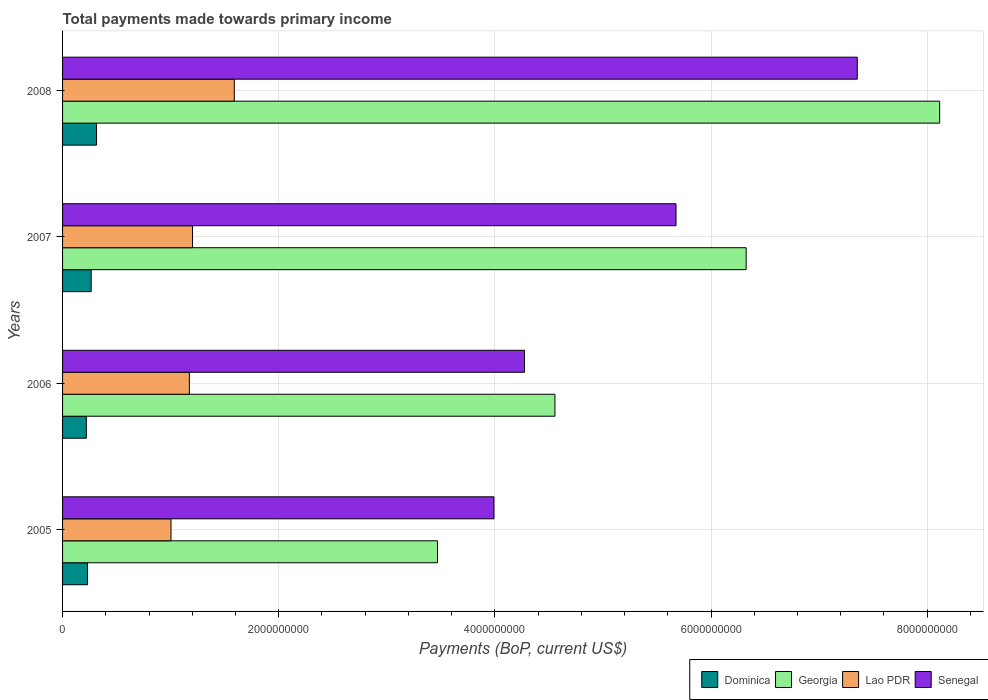How many different coloured bars are there?
Offer a terse response. 4. Are the number of bars per tick equal to the number of legend labels?
Provide a short and direct response. Yes. How many bars are there on the 4th tick from the top?
Your response must be concise. 4. How many bars are there on the 2nd tick from the bottom?
Your answer should be compact. 4. What is the label of the 2nd group of bars from the top?
Provide a short and direct response. 2007. In how many cases, is the number of bars for a given year not equal to the number of legend labels?
Your response must be concise. 0. What is the total payments made towards primary income in Lao PDR in 2008?
Make the answer very short. 1.59e+09. Across all years, what is the maximum total payments made towards primary income in Dominica?
Provide a short and direct response. 3.14e+08. Across all years, what is the minimum total payments made towards primary income in Georgia?
Your response must be concise. 3.47e+09. In which year was the total payments made towards primary income in Dominica minimum?
Provide a short and direct response. 2006. What is the total total payments made towards primary income in Senegal in the graph?
Ensure brevity in your answer.  2.13e+1. What is the difference between the total payments made towards primary income in Dominica in 2007 and that in 2008?
Provide a short and direct response. -4.96e+07. What is the difference between the total payments made towards primary income in Georgia in 2008 and the total payments made towards primary income in Senegal in 2007?
Your response must be concise. 2.44e+09. What is the average total payments made towards primary income in Dominica per year?
Your response must be concise. 2.57e+08. In the year 2007, what is the difference between the total payments made towards primary income in Senegal and total payments made towards primary income in Dominica?
Your response must be concise. 5.41e+09. In how many years, is the total payments made towards primary income in Senegal greater than 8000000000 US$?
Your response must be concise. 0. What is the ratio of the total payments made towards primary income in Senegal in 2005 to that in 2006?
Offer a very short reply. 0.93. Is the difference between the total payments made towards primary income in Senegal in 2007 and 2008 greater than the difference between the total payments made towards primary income in Dominica in 2007 and 2008?
Offer a terse response. No. What is the difference between the highest and the second highest total payments made towards primary income in Dominica?
Your answer should be very brief. 4.96e+07. What is the difference between the highest and the lowest total payments made towards primary income in Georgia?
Your answer should be compact. 4.65e+09. In how many years, is the total payments made towards primary income in Senegal greater than the average total payments made towards primary income in Senegal taken over all years?
Your answer should be compact. 2. Is the sum of the total payments made towards primary income in Lao PDR in 2006 and 2008 greater than the maximum total payments made towards primary income in Georgia across all years?
Offer a very short reply. No. Is it the case that in every year, the sum of the total payments made towards primary income in Lao PDR and total payments made towards primary income in Georgia is greater than the sum of total payments made towards primary income in Dominica and total payments made towards primary income in Senegal?
Make the answer very short. Yes. What does the 3rd bar from the top in 2006 represents?
Your answer should be compact. Georgia. What does the 1st bar from the bottom in 2005 represents?
Make the answer very short. Dominica. How many bars are there?
Ensure brevity in your answer.  16. Are all the bars in the graph horizontal?
Your answer should be very brief. Yes. What is the difference between two consecutive major ticks on the X-axis?
Your answer should be compact. 2.00e+09. Where does the legend appear in the graph?
Make the answer very short. Bottom right. How many legend labels are there?
Provide a succinct answer. 4. What is the title of the graph?
Your response must be concise. Total payments made towards primary income. Does "Albania" appear as one of the legend labels in the graph?
Your response must be concise. No. What is the label or title of the X-axis?
Make the answer very short. Payments (BoP, current US$). What is the Payments (BoP, current US$) in Dominica in 2005?
Give a very brief answer. 2.31e+08. What is the Payments (BoP, current US$) in Georgia in 2005?
Offer a terse response. 3.47e+09. What is the Payments (BoP, current US$) of Lao PDR in 2005?
Give a very brief answer. 1.00e+09. What is the Payments (BoP, current US$) of Senegal in 2005?
Your answer should be compact. 3.99e+09. What is the Payments (BoP, current US$) of Dominica in 2006?
Your answer should be very brief. 2.20e+08. What is the Payments (BoP, current US$) in Georgia in 2006?
Your response must be concise. 4.56e+09. What is the Payments (BoP, current US$) in Lao PDR in 2006?
Offer a very short reply. 1.17e+09. What is the Payments (BoP, current US$) of Senegal in 2006?
Your answer should be very brief. 4.27e+09. What is the Payments (BoP, current US$) of Dominica in 2007?
Keep it short and to the point. 2.64e+08. What is the Payments (BoP, current US$) of Georgia in 2007?
Keep it short and to the point. 6.32e+09. What is the Payments (BoP, current US$) in Lao PDR in 2007?
Your answer should be compact. 1.20e+09. What is the Payments (BoP, current US$) of Senegal in 2007?
Offer a very short reply. 5.68e+09. What is the Payments (BoP, current US$) of Dominica in 2008?
Your answer should be very brief. 3.14e+08. What is the Payments (BoP, current US$) in Georgia in 2008?
Provide a succinct answer. 8.11e+09. What is the Payments (BoP, current US$) of Lao PDR in 2008?
Make the answer very short. 1.59e+09. What is the Payments (BoP, current US$) in Senegal in 2008?
Give a very brief answer. 7.35e+09. Across all years, what is the maximum Payments (BoP, current US$) in Dominica?
Your answer should be compact. 3.14e+08. Across all years, what is the maximum Payments (BoP, current US$) of Georgia?
Your answer should be compact. 8.11e+09. Across all years, what is the maximum Payments (BoP, current US$) in Lao PDR?
Your answer should be very brief. 1.59e+09. Across all years, what is the maximum Payments (BoP, current US$) of Senegal?
Provide a short and direct response. 7.35e+09. Across all years, what is the minimum Payments (BoP, current US$) of Dominica?
Provide a short and direct response. 2.20e+08. Across all years, what is the minimum Payments (BoP, current US$) in Georgia?
Keep it short and to the point. 3.47e+09. Across all years, what is the minimum Payments (BoP, current US$) in Lao PDR?
Ensure brevity in your answer.  1.00e+09. Across all years, what is the minimum Payments (BoP, current US$) in Senegal?
Provide a short and direct response. 3.99e+09. What is the total Payments (BoP, current US$) of Dominica in the graph?
Ensure brevity in your answer.  1.03e+09. What is the total Payments (BoP, current US$) of Georgia in the graph?
Your response must be concise. 2.25e+1. What is the total Payments (BoP, current US$) of Lao PDR in the graph?
Keep it short and to the point. 4.97e+09. What is the total Payments (BoP, current US$) in Senegal in the graph?
Your answer should be compact. 2.13e+1. What is the difference between the Payments (BoP, current US$) in Dominica in 2005 and that in 2006?
Ensure brevity in your answer.  1.10e+07. What is the difference between the Payments (BoP, current US$) in Georgia in 2005 and that in 2006?
Provide a short and direct response. -1.09e+09. What is the difference between the Payments (BoP, current US$) in Lao PDR in 2005 and that in 2006?
Your answer should be very brief. -1.70e+08. What is the difference between the Payments (BoP, current US$) in Senegal in 2005 and that in 2006?
Provide a succinct answer. -2.83e+08. What is the difference between the Payments (BoP, current US$) in Dominica in 2005 and that in 2007?
Your response must be concise. -3.35e+07. What is the difference between the Payments (BoP, current US$) of Georgia in 2005 and that in 2007?
Your answer should be very brief. -2.86e+09. What is the difference between the Payments (BoP, current US$) in Lao PDR in 2005 and that in 2007?
Your response must be concise. -1.99e+08. What is the difference between the Payments (BoP, current US$) of Senegal in 2005 and that in 2007?
Your answer should be very brief. -1.68e+09. What is the difference between the Payments (BoP, current US$) of Dominica in 2005 and that in 2008?
Your answer should be very brief. -8.30e+07. What is the difference between the Payments (BoP, current US$) of Georgia in 2005 and that in 2008?
Keep it short and to the point. -4.65e+09. What is the difference between the Payments (BoP, current US$) of Lao PDR in 2005 and that in 2008?
Offer a terse response. -5.85e+08. What is the difference between the Payments (BoP, current US$) in Senegal in 2005 and that in 2008?
Provide a succinct answer. -3.36e+09. What is the difference between the Payments (BoP, current US$) in Dominica in 2006 and that in 2007?
Offer a very short reply. -4.45e+07. What is the difference between the Payments (BoP, current US$) of Georgia in 2006 and that in 2007?
Provide a short and direct response. -1.77e+09. What is the difference between the Payments (BoP, current US$) in Lao PDR in 2006 and that in 2007?
Your response must be concise. -2.94e+07. What is the difference between the Payments (BoP, current US$) of Senegal in 2006 and that in 2007?
Ensure brevity in your answer.  -1.40e+09. What is the difference between the Payments (BoP, current US$) of Dominica in 2006 and that in 2008?
Offer a terse response. -9.40e+07. What is the difference between the Payments (BoP, current US$) in Georgia in 2006 and that in 2008?
Offer a very short reply. -3.56e+09. What is the difference between the Payments (BoP, current US$) in Lao PDR in 2006 and that in 2008?
Offer a terse response. -4.16e+08. What is the difference between the Payments (BoP, current US$) in Senegal in 2006 and that in 2008?
Give a very brief answer. -3.08e+09. What is the difference between the Payments (BoP, current US$) of Dominica in 2007 and that in 2008?
Your answer should be compact. -4.96e+07. What is the difference between the Payments (BoP, current US$) of Georgia in 2007 and that in 2008?
Make the answer very short. -1.79e+09. What is the difference between the Payments (BoP, current US$) in Lao PDR in 2007 and that in 2008?
Provide a short and direct response. -3.86e+08. What is the difference between the Payments (BoP, current US$) in Senegal in 2007 and that in 2008?
Provide a succinct answer. -1.68e+09. What is the difference between the Payments (BoP, current US$) in Dominica in 2005 and the Payments (BoP, current US$) in Georgia in 2006?
Give a very brief answer. -4.32e+09. What is the difference between the Payments (BoP, current US$) in Dominica in 2005 and the Payments (BoP, current US$) in Lao PDR in 2006?
Keep it short and to the point. -9.42e+08. What is the difference between the Payments (BoP, current US$) of Dominica in 2005 and the Payments (BoP, current US$) of Senegal in 2006?
Keep it short and to the point. -4.04e+09. What is the difference between the Payments (BoP, current US$) of Georgia in 2005 and the Payments (BoP, current US$) of Lao PDR in 2006?
Offer a very short reply. 2.30e+09. What is the difference between the Payments (BoP, current US$) in Georgia in 2005 and the Payments (BoP, current US$) in Senegal in 2006?
Your answer should be very brief. -8.05e+08. What is the difference between the Payments (BoP, current US$) in Lao PDR in 2005 and the Payments (BoP, current US$) in Senegal in 2006?
Make the answer very short. -3.27e+09. What is the difference between the Payments (BoP, current US$) of Dominica in 2005 and the Payments (BoP, current US$) of Georgia in 2007?
Keep it short and to the point. -6.09e+09. What is the difference between the Payments (BoP, current US$) of Dominica in 2005 and the Payments (BoP, current US$) of Lao PDR in 2007?
Ensure brevity in your answer.  -9.71e+08. What is the difference between the Payments (BoP, current US$) of Dominica in 2005 and the Payments (BoP, current US$) of Senegal in 2007?
Make the answer very short. -5.44e+09. What is the difference between the Payments (BoP, current US$) in Georgia in 2005 and the Payments (BoP, current US$) in Lao PDR in 2007?
Provide a succinct answer. 2.27e+09. What is the difference between the Payments (BoP, current US$) of Georgia in 2005 and the Payments (BoP, current US$) of Senegal in 2007?
Keep it short and to the point. -2.21e+09. What is the difference between the Payments (BoP, current US$) in Lao PDR in 2005 and the Payments (BoP, current US$) in Senegal in 2007?
Offer a very short reply. -4.67e+09. What is the difference between the Payments (BoP, current US$) in Dominica in 2005 and the Payments (BoP, current US$) in Georgia in 2008?
Keep it short and to the point. -7.88e+09. What is the difference between the Payments (BoP, current US$) in Dominica in 2005 and the Payments (BoP, current US$) in Lao PDR in 2008?
Provide a succinct answer. -1.36e+09. What is the difference between the Payments (BoP, current US$) in Dominica in 2005 and the Payments (BoP, current US$) in Senegal in 2008?
Keep it short and to the point. -7.12e+09. What is the difference between the Payments (BoP, current US$) of Georgia in 2005 and the Payments (BoP, current US$) of Lao PDR in 2008?
Provide a short and direct response. 1.88e+09. What is the difference between the Payments (BoP, current US$) in Georgia in 2005 and the Payments (BoP, current US$) in Senegal in 2008?
Offer a very short reply. -3.88e+09. What is the difference between the Payments (BoP, current US$) in Lao PDR in 2005 and the Payments (BoP, current US$) in Senegal in 2008?
Offer a terse response. -6.35e+09. What is the difference between the Payments (BoP, current US$) of Dominica in 2006 and the Payments (BoP, current US$) of Georgia in 2007?
Your answer should be very brief. -6.10e+09. What is the difference between the Payments (BoP, current US$) of Dominica in 2006 and the Payments (BoP, current US$) of Lao PDR in 2007?
Keep it short and to the point. -9.82e+08. What is the difference between the Payments (BoP, current US$) of Dominica in 2006 and the Payments (BoP, current US$) of Senegal in 2007?
Offer a terse response. -5.46e+09. What is the difference between the Payments (BoP, current US$) of Georgia in 2006 and the Payments (BoP, current US$) of Lao PDR in 2007?
Your answer should be compact. 3.35e+09. What is the difference between the Payments (BoP, current US$) of Georgia in 2006 and the Payments (BoP, current US$) of Senegal in 2007?
Make the answer very short. -1.12e+09. What is the difference between the Payments (BoP, current US$) of Lao PDR in 2006 and the Payments (BoP, current US$) of Senegal in 2007?
Provide a succinct answer. -4.50e+09. What is the difference between the Payments (BoP, current US$) of Dominica in 2006 and the Payments (BoP, current US$) of Georgia in 2008?
Your response must be concise. -7.89e+09. What is the difference between the Payments (BoP, current US$) of Dominica in 2006 and the Payments (BoP, current US$) of Lao PDR in 2008?
Make the answer very short. -1.37e+09. What is the difference between the Payments (BoP, current US$) of Dominica in 2006 and the Payments (BoP, current US$) of Senegal in 2008?
Provide a short and direct response. -7.13e+09. What is the difference between the Payments (BoP, current US$) of Georgia in 2006 and the Payments (BoP, current US$) of Lao PDR in 2008?
Keep it short and to the point. 2.97e+09. What is the difference between the Payments (BoP, current US$) of Georgia in 2006 and the Payments (BoP, current US$) of Senegal in 2008?
Keep it short and to the point. -2.80e+09. What is the difference between the Payments (BoP, current US$) in Lao PDR in 2006 and the Payments (BoP, current US$) in Senegal in 2008?
Keep it short and to the point. -6.18e+09. What is the difference between the Payments (BoP, current US$) of Dominica in 2007 and the Payments (BoP, current US$) of Georgia in 2008?
Your answer should be compact. -7.85e+09. What is the difference between the Payments (BoP, current US$) of Dominica in 2007 and the Payments (BoP, current US$) of Lao PDR in 2008?
Your answer should be compact. -1.32e+09. What is the difference between the Payments (BoP, current US$) of Dominica in 2007 and the Payments (BoP, current US$) of Senegal in 2008?
Your response must be concise. -7.09e+09. What is the difference between the Payments (BoP, current US$) of Georgia in 2007 and the Payments (BoP, current US$) of Lao PDR in 2008?
Offer a terse response. 4.74e+09. What is the difference between the Payments (BoP, current US$) in Georgia in 2007 and the Payments (BoP, current US$) in Senegal in 2008?
Give a very brief answer. -1.03e+09. What is the difference between the Payments (BoP, current US$) of Lao PDR in 2007 and the Payments (BoP, current US$) of Senegal in 2008?
Make the answer very short. -6.15e+09. What is the average Payments (BoP, current US$) in Dominica per year?
Your answer should be very brief. 2.57e+08. What is the average Payments (BoP, current US$) in Georgia per year?
Your answer should be very brief. 5.62e+09. What is the average Payments (BoP, current US$) of Lao PDR per year?
Offer a terse response. 1.24e+09. What is the average Payments (BoP, current US$) of Senegal per year?
Make the answer very short. 5.32e+09. In the year 2005, what is the difference between the Payments (BoP, current US$) of Dominica and Payments (BoP, current US$) of Georgia?
Offer a very short reply. -3.24e+09. In the year 2005, what is the difference between the Payments (BoP, current US$) in Dominica and Payments (BoP, current US$) in Lao PDR?
Your response must be concise. -7.72e+08. In the year 2005, what is the difference between the Payments (BoP, current US$) of Dominica and Payments (BoP, current US$) of Senegal?
Offer a terse response. -3.76e+09. In the year 2005, what is the difference between the Payments (BoP, current US$) in Georgia and Payments (BoP, current US$) in Lao PDR?
Your answer should be very brief. 2.47e+09. In the year 2005, what is the difference between the Payments (BoP, current US$) of Georgia and Payments (BoP, current US$) of Senegal?
Your response must be concise. -5.22e+08. In the year 2005, what is the difference between the Payments (BoP, current US$) of Lao PDR and Payments (BoP, current US$) of Senegal?
Give a very brief answer. -2.99e+09. In the year 2006, what is the difference between the Payments (BoP, current US$) in Dominica and Payments (BoP, current US$) in Georgia?
Make the answer very short. -4.34e+09. In the year 2006, what is the difference between the Payments (BoP, current US$) of Dominica and Payments (BoP, current US$) of Lao PDR?
Make the answer very short. -9.53e+08. In the year 2006, what is the difference between the Payments (BoP, current US$) of Dominica and Payments (BoP, current US$) of Senegal?
Provide a short and direct response. -4.05e+09. In the year 2006, what is the difference between the Payments (BoP, current US$) of Georgia and Payments (BoP, current US$) of Lao PDR?
Your answer should be very brief. 3.38e+09. In the year 2006, what is the difference between the Payments (BoP, current US$) of Georgia and Payments (BoP, current US$) of Senegal?
Provide a short and direct response. 2.81e+08. In the year 2006, what is the difference between the Payments (BoP, current US$) in Lao PDR and Payments (BoP, current US$) in Senegal?
Make the answer very short. -3.10e+09. In the year 2007, what is the difference between the Payments (BoP, current US$) in Dominica and Payments (BoP, current US$) in Georgia?
Offer a terse response. -6.06e+09. In the year 2007, what is the difference between the Payments (BoP, current US$) in Dominica and Payments (BoP, current US$) in Lao PDR?
Make the answer very short. -9.38e+08. In the year 2007, what is the difference between the Payments (BoP, current US$) of Dominica and Payments (BoP, current US$) of Senegal?
Give a very brief answer. -5.41e+09. In the year 2007, what is the difference between the Payments (BoP, current US$) of Georgia and Payments (BoP, current US$) of Lao PDR?
Keep it short and to the point. 5.12e+09. In the year 2007, what is the difference between the Payments (BoP, current US$) of Georgia and Payments (BoP, current US$) of Senegal?
Offer a very short reply. 6.49e+08. In the year 2007, what is the difference between the Payments (BoP, current US$) of Lao PDR and Payments (BoP, current US$) of Senegal?
Offer a very short reply. -4.47e+09. In the year 2008, what is the difference between the Payments (BoP, current US$) in Dominica and Payments (BoP, current US$) in Georgia?
Offer a terse response. -7.80e+09. In the year 2008, what is the difference between the Payments (BoP, current US$) in Dominica and Payments (BoP, current US$) in Lao PDR?
Provide a succinct answer. -1.27e+09. In the year 2008, what is the difference between the Payments (BoP, current US$) of Dominica and Payments (BoP, current US$) of Senegal?
Make the answer very short. -7.04e+09. In the year 2008, what is the difference between the Payments (BoP, current US$) in Georgia and Payments (BoP, current US$) in Lao PDR?
Your response must be concise. 6.53e+09. In the year 2008, what is the difference between the Payments (BoP, current US$) in Georgia and Payments (BoP, current US$) in Senegal?
Your response must be concise. 7.62e+08. In the year 2008, what is the difference between the Payments (BoP, current US$) in Lao PDR and Payments (BoP, current US$) in Senegal?
Make the answer very short. -5.76e+09. What is the ratio of the Payments (BoP, current US$) of Georgia in 2005 to that in 2006?
Offer a terse response. 0.76. What is the ratio of the Payments (BoP, current US$) in Lao PDR in 2005 to that in 2006?
Offer a terse response. 0.86. What is the ratio of the Payments (BoP, current US$) in Senegal in 2005 to that in 2006?
Ensure brevity in your answer.  0.93. What is the ratio of the Payments (BoP, current US$) of Dominica in 2005 to that in 2007?
Provide a succinct answer. 0.87. What is the ratio of the Payments (BoP, current US$) of Georgia in 2005 to that in 2007?
Your answer should be compact. 0.55. What is the ratio of the Payments (BoP, current US$) in Lao PDR in 2005 to that in 2007?
Ensure brevity in your answer.  0.83. What is the ratio of the Payments (BoP, current US$) in Senegal in 2005 to that in 2007?
Your response must be concise. 0.7. What is the ratio of the Payments (BoP, current US$) of Dominica in 2005 to that in 2008?
Provide a short and direct response. 0.74. What is the ratio of the Payments (BoP, current US$) of Georgia in 2005 to that in 2008?
Offer a terse response. 0.43. What is the ratio of the Payments (BoP, current US$) in Lao PDR in 2005 to that in 2008?
Keep it short and to the point. 0.63. What is the ratio of the Payments (BoP, current US$) in Senegal in 2005 to that in 2008?
Your answer should be compact. 0.54. What is the ratio of the Payments (BoP, current US$) in Dominica in 2006 to that in 2007?
Give a very brief answer. 0.83. What is the ratio of the Payments (BoP, current US$) of Georgia in 2006 to that in 2007?
Keep it short and to the point. 0.72. What is the ratio of the Payments (BoP, current US$) in Lao PDR in 2006 to that in 2007?
Provide a succinct answer. 0.98. What is the ratio of the Payments (BoP, current US$) of Senegal in 2006 to that in 2007?
Your response must be concise. 0.75. What is the ratio of the Payments (BoP, current US$) in Dominica in 2006 to that in 2008?
Make the answer very short. 0.7. What is the ratio of the Payments (BoP, current US$) in Georgia in 2006 to that in 2008?
Ensure brevity in your answer.  0.56. What is the ratio of the Payments (BoP, current US$) of Lao PDR in 2006 to that in 2008?
Your response must be concise. 0.74. What is the ratio of the Payments (BoP, current US$) in Senegal in 2006 to that in 2008?
Your answer should be very brief. 0.58. What is the ratio of the Payments (BoP, current US$) of Dominica in 2007 to that in 2008?
Your answer should be very brief. 0.84. What is the ratio of the Payments (BoP, current US$) of Georgia in 2007 to that in 2008?
Your response must be concise. 0.78. What is the ratio of the Payments (BoP, current US$) of Lao PDR in 2007 to that in 2008?
Your answer should be very brief. 0.76. What is the ratio of the Payments (BoP, current US$) of Senegal in 2007 to that in 2008?
Ensure brevity in your answer.  0.77. What is the difference between the highest and the second highest Payments (BoP, current US$) in Dominica?
Ensure brevity in your answer.  4.96e+07. What is the difference between the highest and the second highest Payments (BoP, current US$) of Georgia?
Provide a succinct answer. 1.79e+09. What is the difference between the highest and the second highest Payments (BoP, current US$) of Lao PDR?
Make the answer very short. 3.86e+08. What is the difference between the highest and the second highest Payments (BoP, current US$) in Senegal?
Ensure brevity in your answer.  1.68e+09. What is the difference between the highest and the lowest Payments (BoP, current US$) of Dominica?
Your answer should be very brief. 9.40e+07. What is the difference between the highest and the lowest Payments (BoP, current US$) in Georgia?
Give a very brief answer. 4.65e+09. What is the difference between the highest and the lowest Payments (BoP, current US$) of Lao PDR?
Keep it short and to the point. 5.85e+08. What is the difference between the highest and the lowest Payments (BoP, current US$) of Senegal?
Make the answer very short. 3.36e+09. 